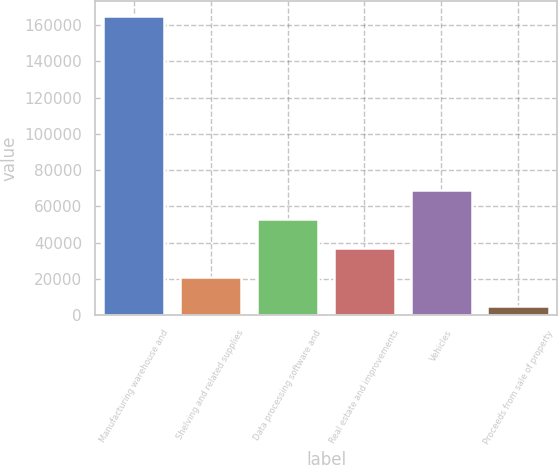<chart> <loc_0><loc_0><loc_500><loc_500><bar_chart><fcel>Manufacturing warehouse and<fcel>Shelving and related supplies<fcel>Data processing software and<fcel>Real estate and improvements<fcel>Vehicles<fcel>Proceeds from sale of property<nl><fcel>164940<fcel>20985<fcel>52975<fcel>36980<fcel>68970<fcel>4990<nl></chart> 